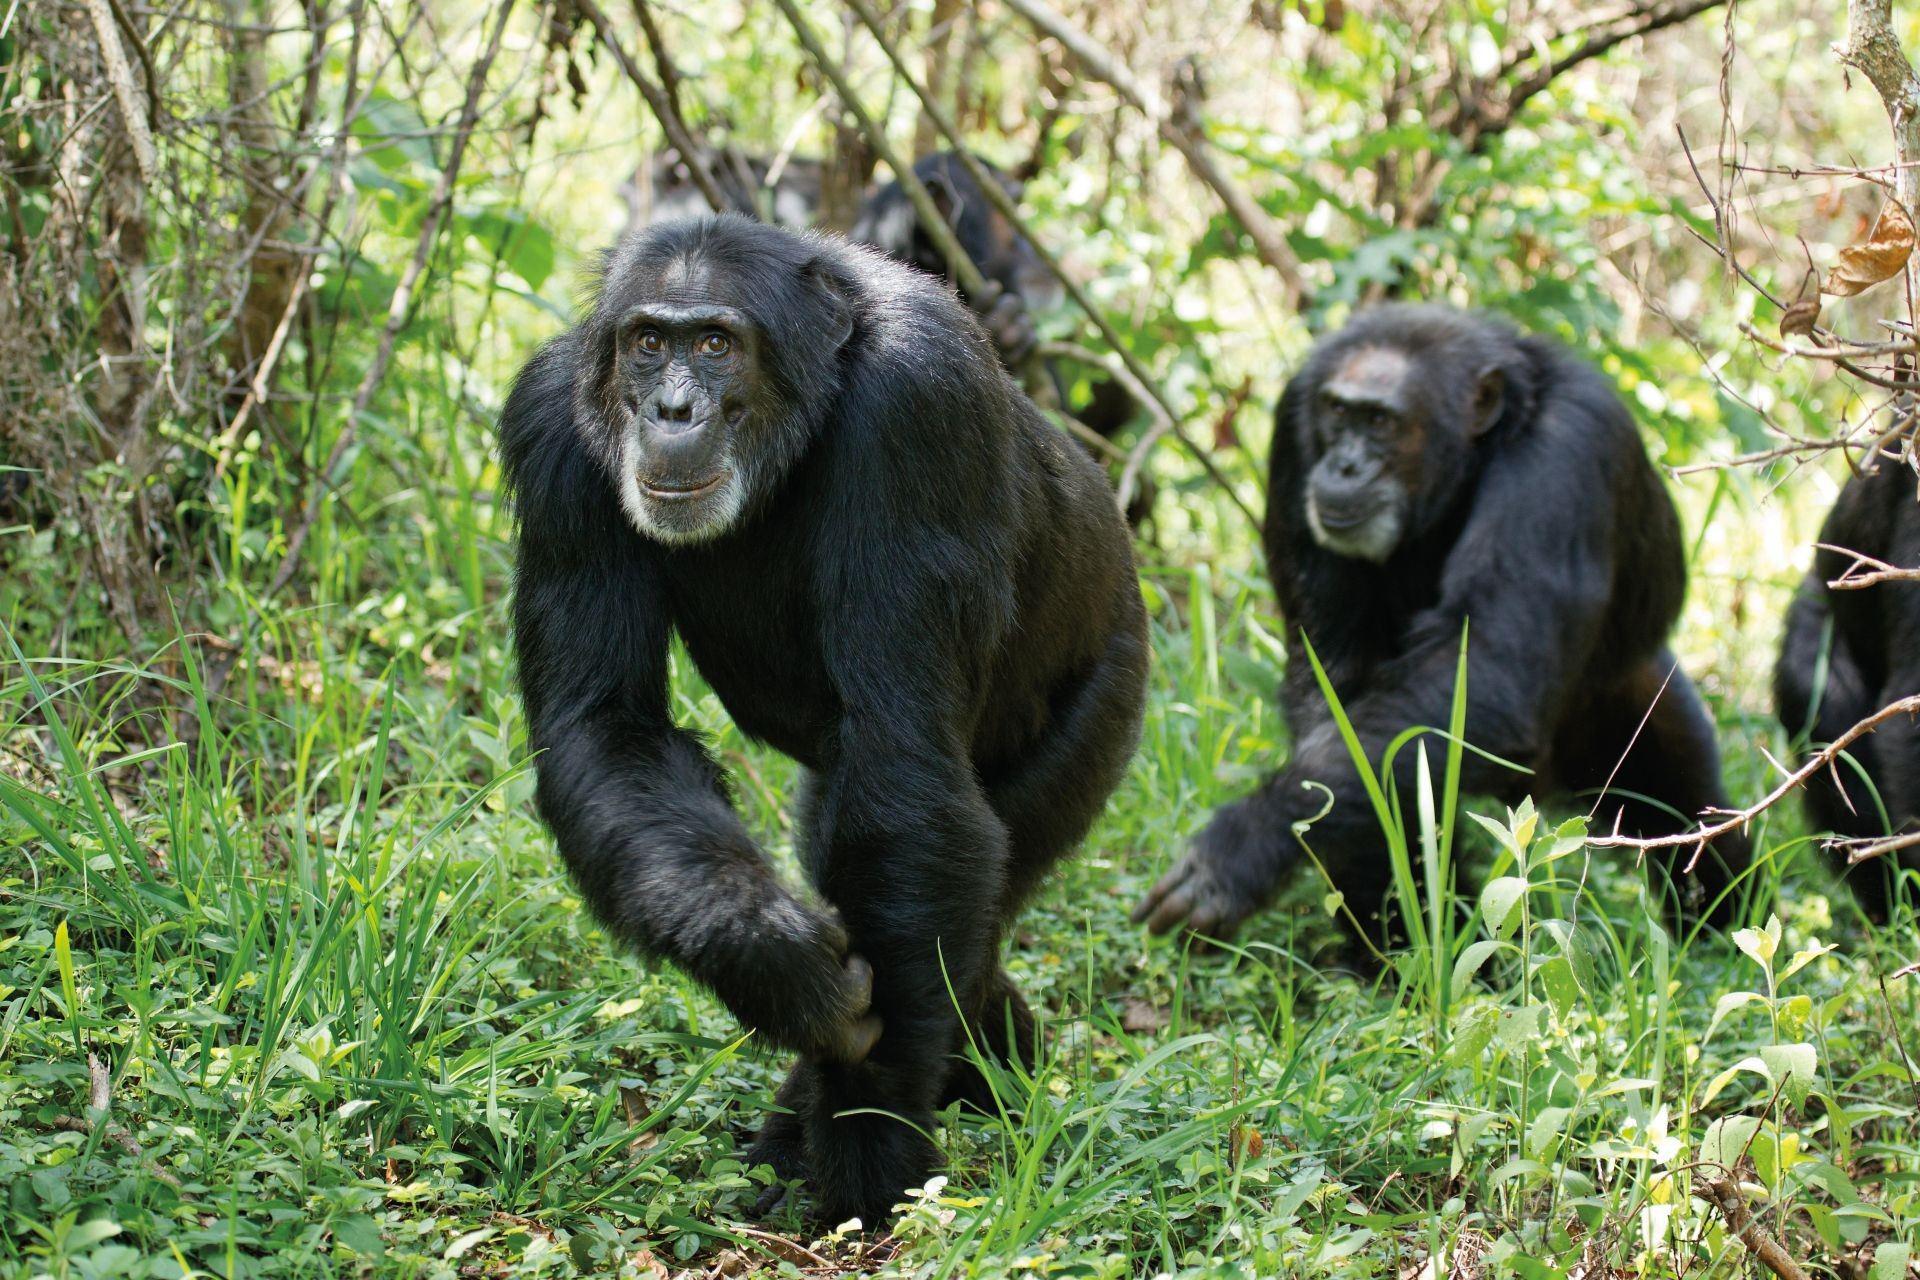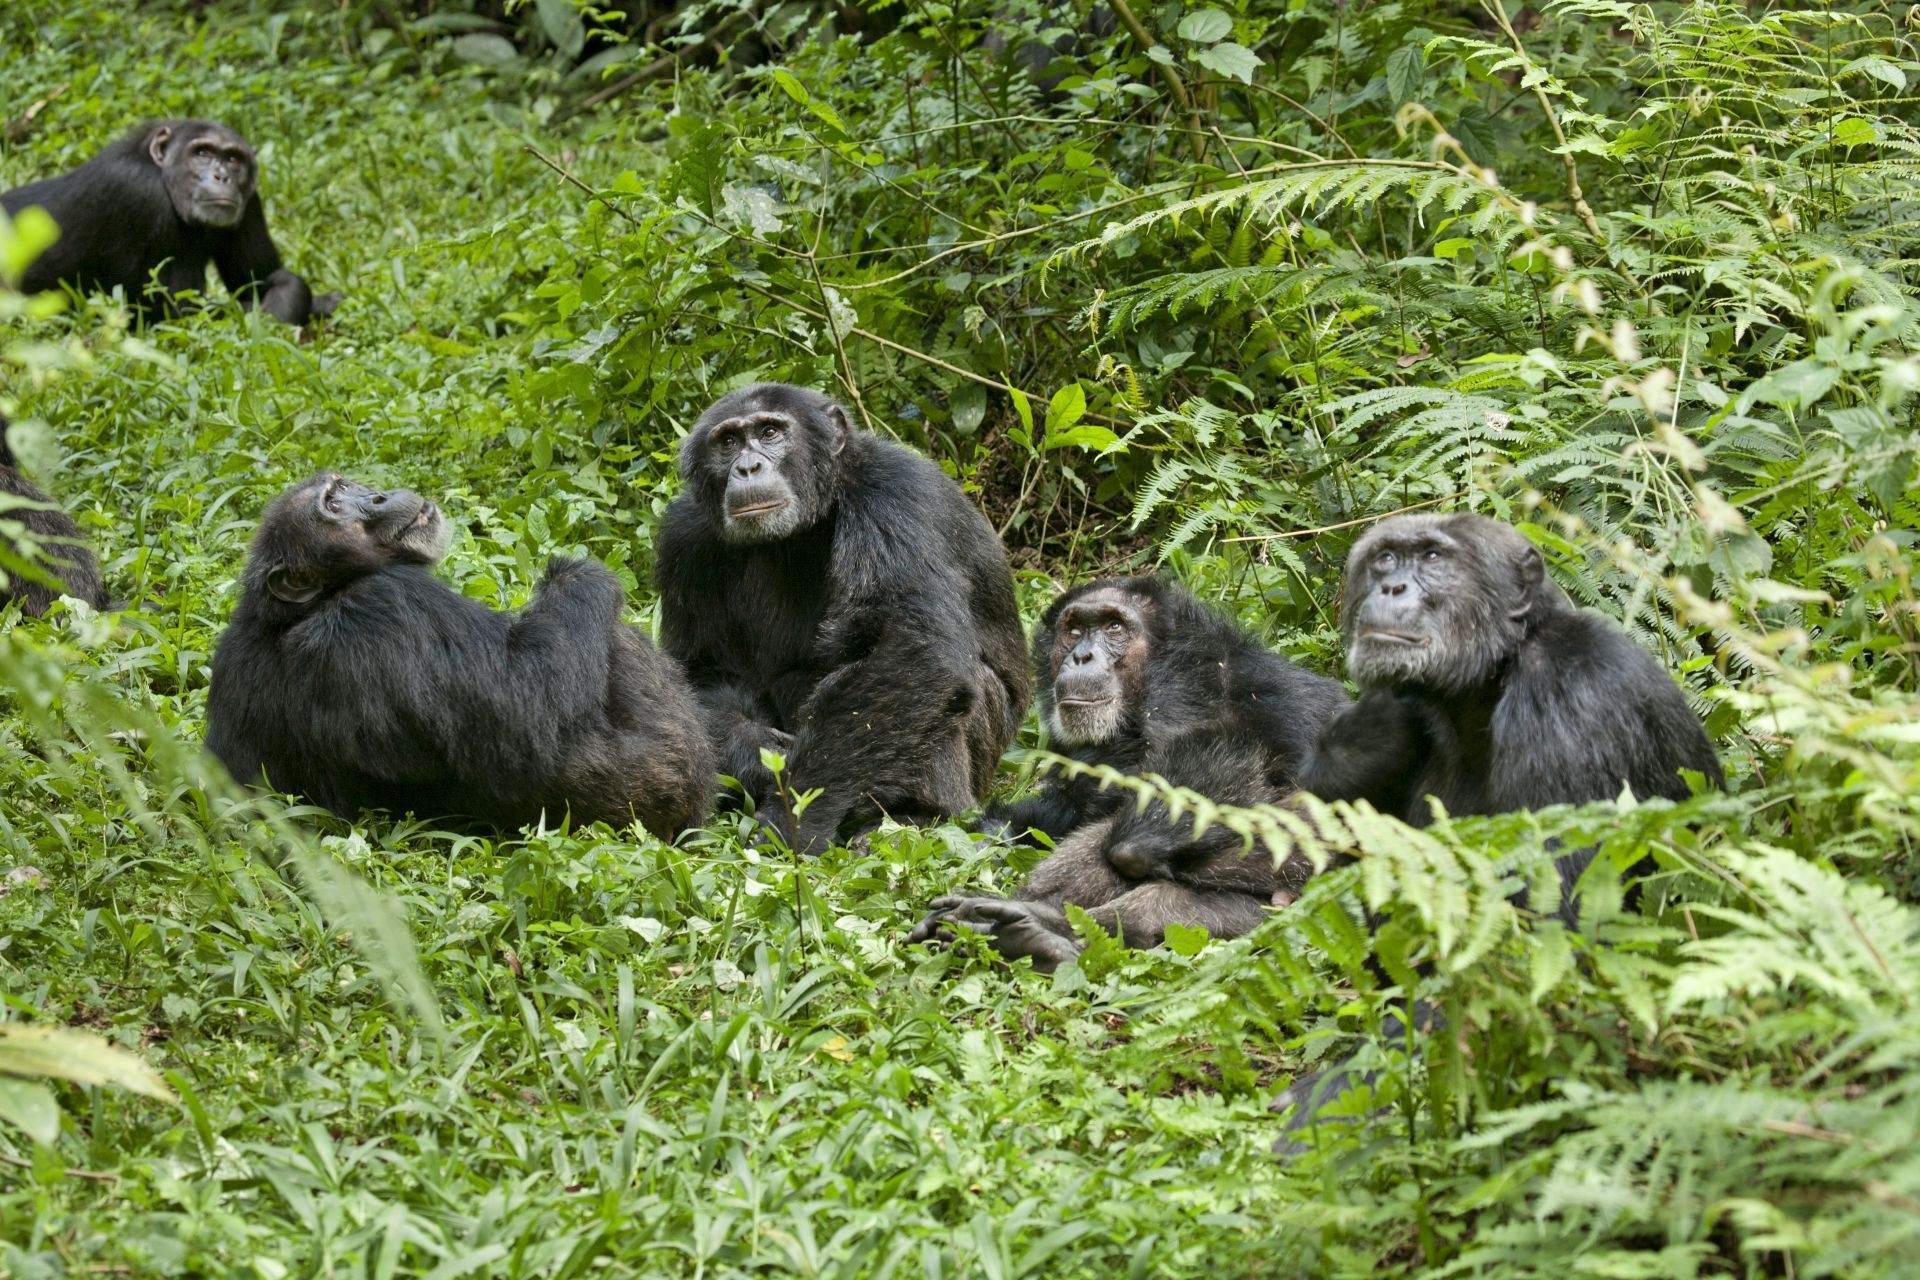The first image is the image on the left, the second image is the image on the right. Given the left and right images, does the statement "An image shows a trio of chimps in a row up off the ground on something branch-like." hold true? Answer yes or no. No. The first image is the image on the left, the second image is the image on the right. Given the left and right images, does the statement "Some apes are holding food in their hands." hold true? Answer yes or no. No. 